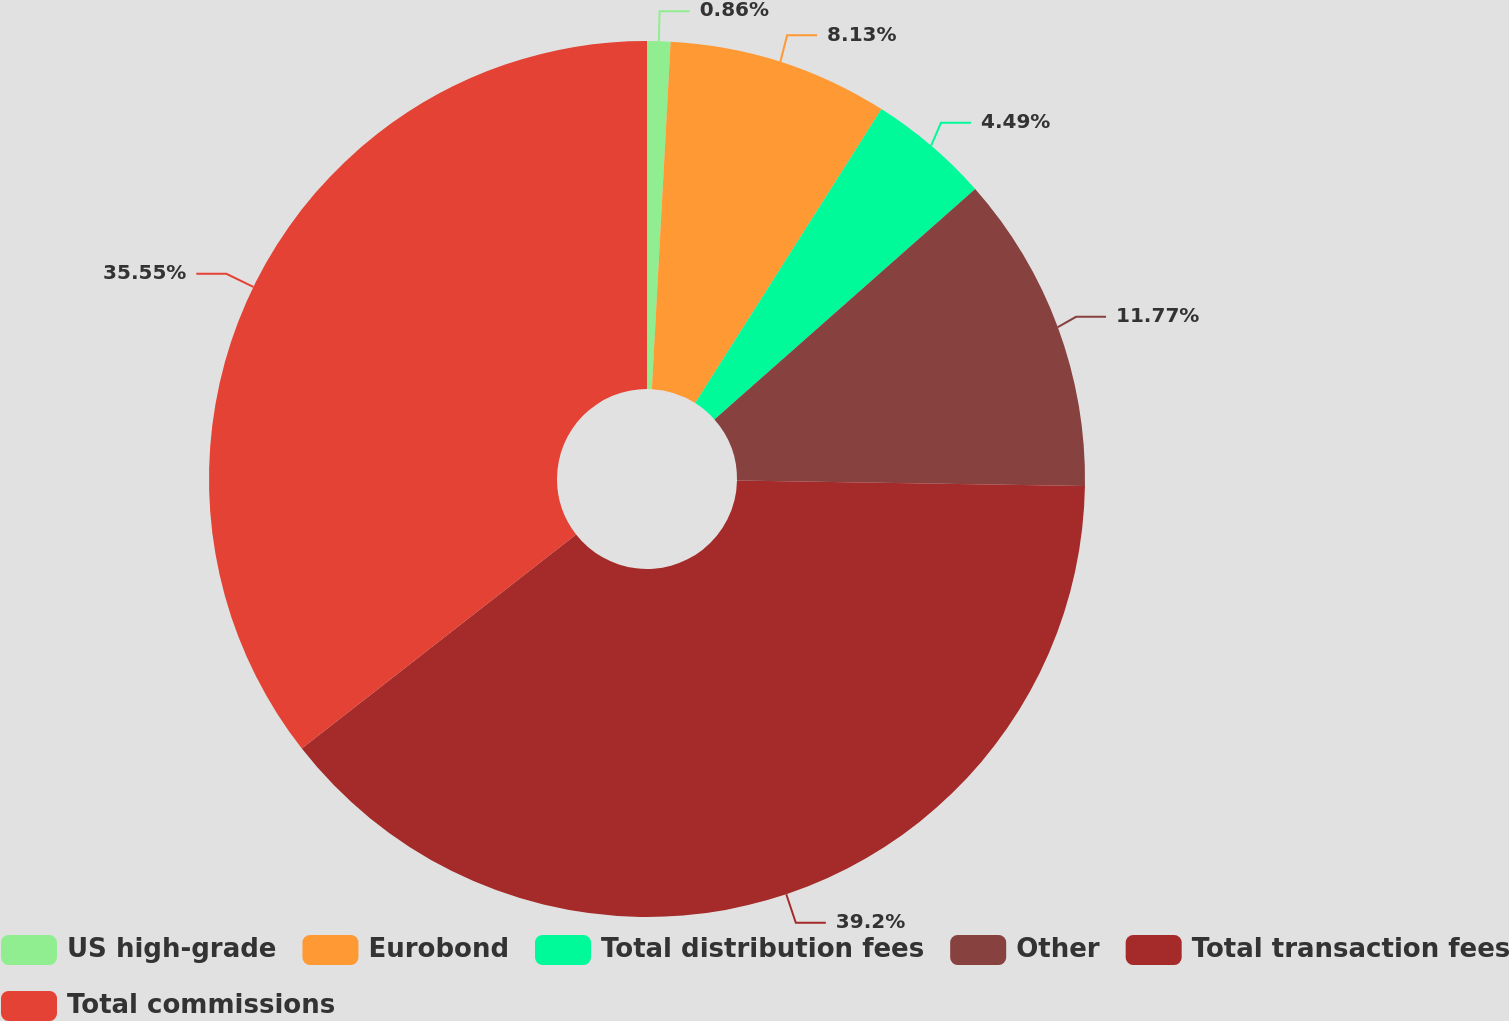<chart> <loc_0><loc_0><loc_500><loc_500><pie_chart><fcel>US high-grade<fcel>Eurobond<fcel>Total distribution fees<fcel>Other<fcel>Total transaction fees<fcel>Total commissions<nl><fcel>0.86%<fcel>8.13%<fcel>4.49%<fcel>11.77%<fcel>39.19%<fcel>35.55%<nl></chart> 